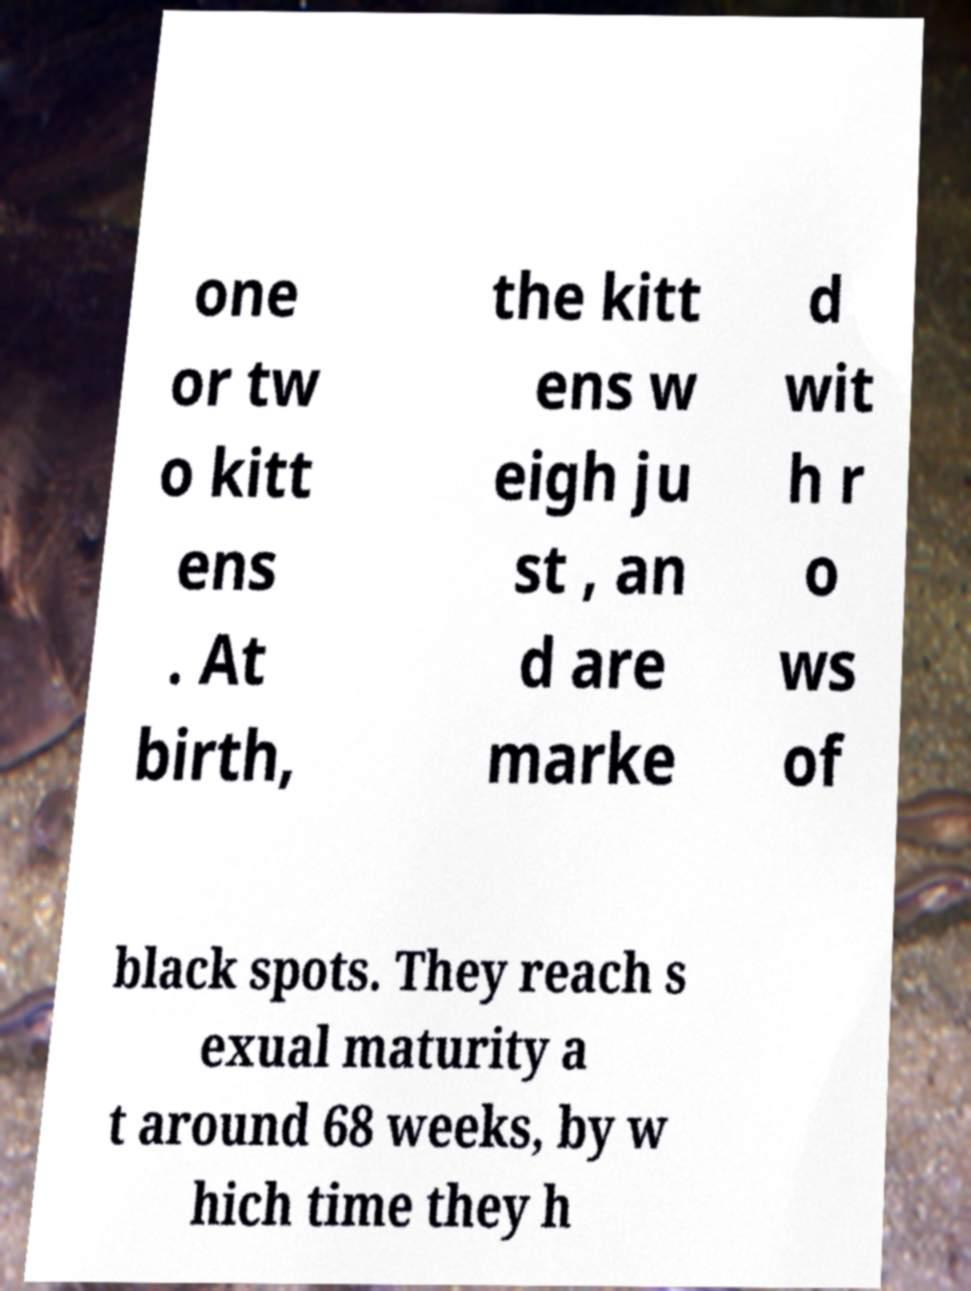Could you extract and type out the text from this image? one or tw o kitt ens . At birth, the kitt ens w eigh ju st , an d are marke d wit h r o ws of black spots. They reach s exual maturity a t around 68 weeks, by w hich time they h 